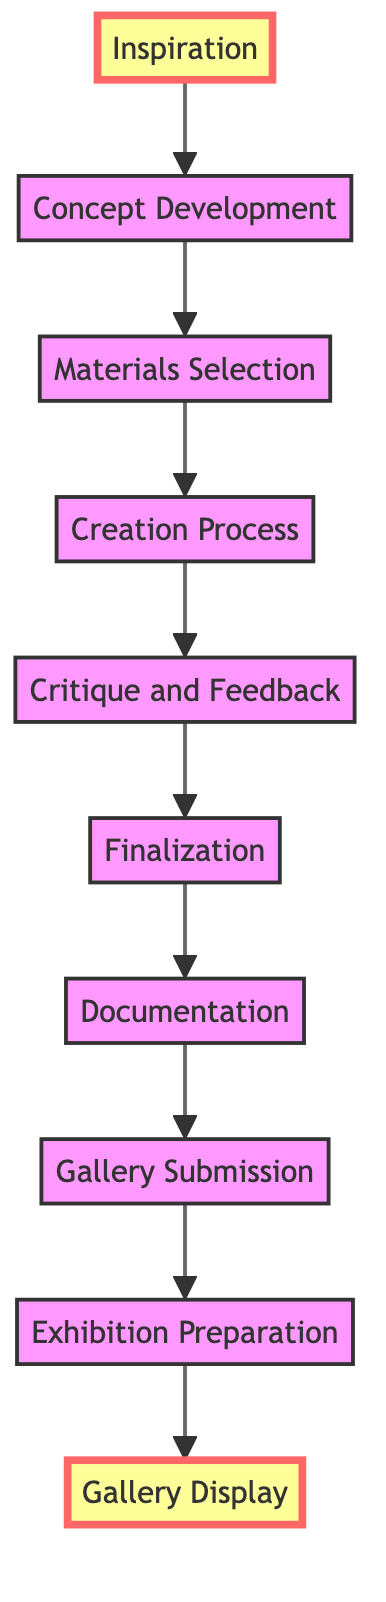What is the first stage in the journey of an artwork? The first stage mentioned in the flow chart is "Inspiration."
Answer: Inspiration How many stages are there in total according to the diagram? By counting the stages listed in the flow chart, there are 10 distinct stages from Inspiration to Gallery Display.
Answer: 10 What follows after "Materials Selection"? After "Materials Selection," the next stage is "Creation Process."
Answer: Creation Process Which stage involves receiving critique? The stage that involves receiving critique is "Critique and Feedback."
Answer: Critique and Feedback What is the last stage in the artwork's journey? The last stage in the journey of an artwork is "Gallery Display."
Answer: Gallery Display What do the highlighted stages represent in the diagram? The highlighted stages, "Inspiration" and "Gallery Display," signify the starting and ending points of the artwork's journey.
Answer: Starting and ending points What are the two main activities during the "Finalization" stage? During the "Finalization" stage, the activities include signing and varnishing the artwork.
Answer: Signing, varnishing Which stages are directly connected to "Creation Process"? The stages directly connected to "Creation Process" are "Materials Selection" leading to it and "Critique and Feedback" following it.
Answer: Materials Selection, Critique and Feedback What type of art is being developed during the "Creation Process"? The artwork being developed during the "Creation Process" can vary by medium but includes forms like paintings or digital art.
Answer: Varies by medium Which stage comes immediately before "Gallery Submission"? The stage that comes immediately before "Gallery Submission" is "Documentation."
Answer: Documentation 